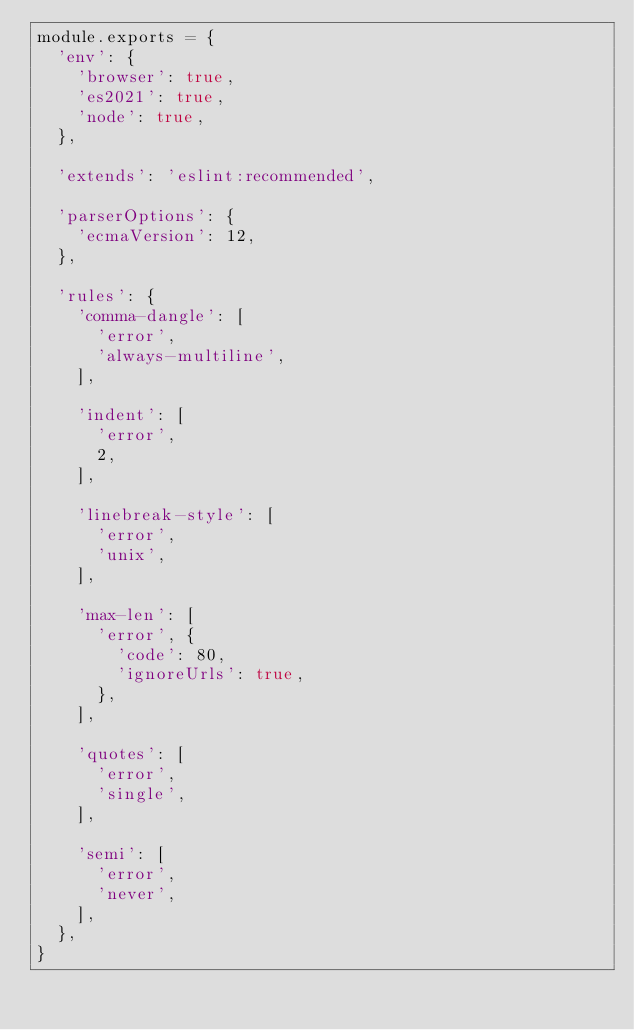Convert code to text. <code><loc_0><loc_0><loc_500><loc_500><_JavaScript_>module.exports = {
  'env': {
    'browser': true,
    'es2021': true,
    'node': true,
  },

  'extends': 'eslint:recommended',

  'parserOptions': {
    'ecmaVersion': 12,
  },

  'rules': {
    'comma-dangle': [
      'error',
      'always-multiline',
    ],

    'indent': [
      'error',
      2,
    ],

    'linebreak-style': [
      'error',
      'unix',
    ],

    'max-len': [
      'error', {
        'code': 80,
        'ignoreUrls': true,
      },
    ],

    'quotes': [
      'error',
      'single',
    ],

    'semi': [
      'error',
      'never',
    ],
  },
}
</code> 